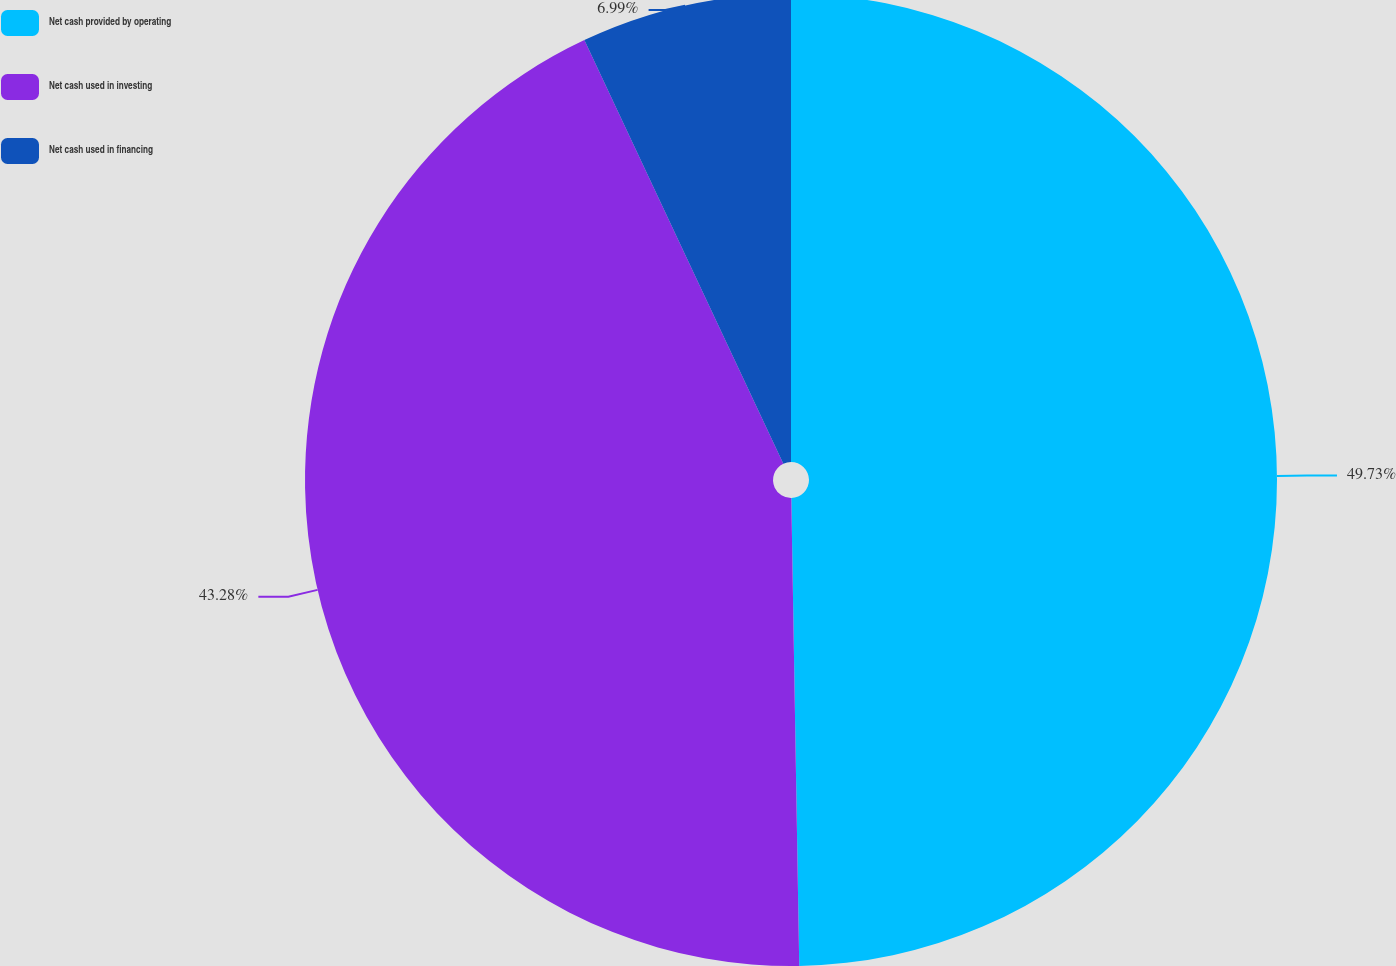Convert chart to OTSL. <chart><loc_0><loc_0><loc_500><loc_500><pie_chart><fcel>Net cash provided by operating<fcel>Net cash used in investing<fcel>Net cash used in financing<nl><fcel>49.73%<fcel>43.28%<fcel>6.99%<nl></chart> 